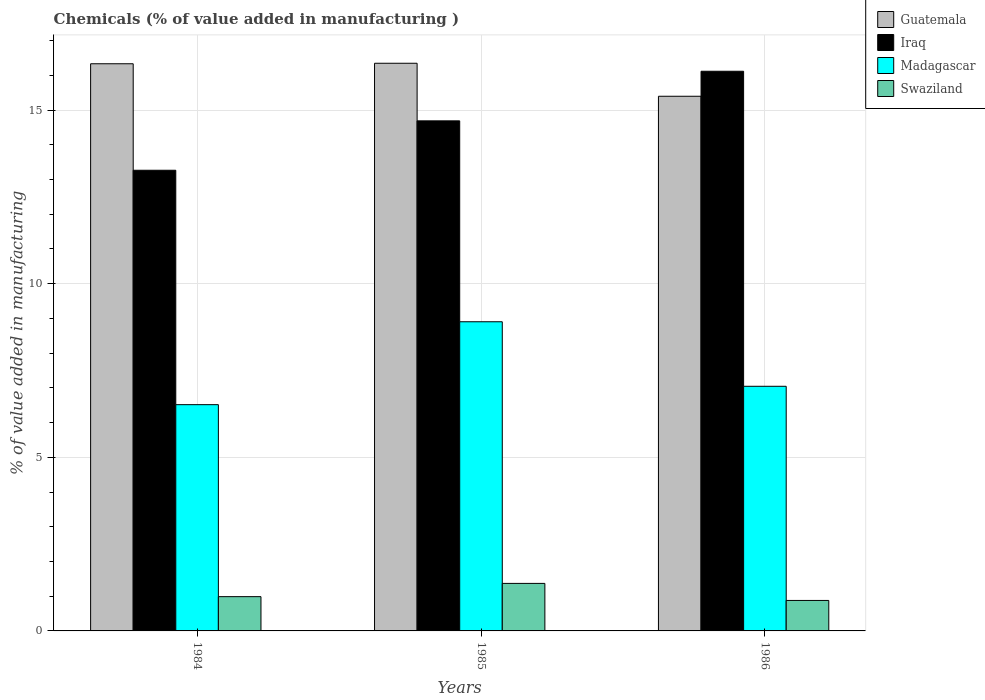Are the number of bars per tick equal to the number of legend labels?
Keep it short and to the point. Yes. How many bars are there on the 1st tick from the right?
Your answer should be compact. 4. What is the value added in manufacturing chemicals in Madagascar in 1985?
Keep it short and to the point. 8.9. Across all years, what is the maximum value added in manufacturing chemicals in Iraq?
Your answer should be compact. 16.12. Across all years, what is the minimum value added in manufacturing chemicals in Iraq?
Offer a terse response. 13.27. What is the total value added in manufacturing chemicals in Madagascar in the graph?
Offer a very short reply. 22.46. What is the difference between the value added in manufacturing chemicals in Iraq in 1985 and that in 1986?
Ensure brevity in your answer.  -1.43. What is the difference between the value added in manufacturing chemicals in Guatemala in 1986 and the value added in manufacturing chemicals in Swaziland in 1984?
Ensure brevity in your answer.  14.41. What is the average value added in manufacturing chemicals in Iraq per year?
Your response must be concise. 14.69. In the year 1986, what is the difference between the value added in manufacturing chemicals in Iraq and value added in manufacturing chemicals in Madagascar?
Make the answer very short. 9.07. What is the ratio of the value added in manufacturing chemicals in Madagascar in 1984 to that in 1985?
Keep it short and to the point. 0.73. What is the difference between the highest and the second highest value added in manufacturing chemicals in Madagascar?
Provide a short and direct response. 1.86. What is the difference between the highest and the lowest value added in manufacturing chemicals in Swaziland?
Offer a very short reply. 0.49. In how many years, is the value added in manufacturing chemicals in Iraq greater than the average value added in manufacturing chemicals in Iraq taken over all years?
Provide a succinct answer. 1. What does the 1st bar from the left in 1986 represents?
Ensure brevity in your answer.  Guatemala. What does the 2nd bar from the right in 1984 represents?
Your answer should be very brief. Madagascar. Is it the case that in every year, the sum of the value added in manufacturing chemicals in Iraq and value added in manufacturing chemicals in Madagascar is greater than the value added in manufacturing chemicals in Guatemala?
Ensure brevity in your answer.  Yes. Where does the legend appear in the graph?
Keep it short and to the point. Top right. What is the title of the graph?
Your response must be concise. Chemicals (% of value added in manufacturing ). What is the label or title of the Y-axis?
Offer a terse response. % of value added in manufacturing. What is the % of value added in manufacturing in Guatemala in 1984?
Your answer should be compact. 16.33. What is the % of value added in manufacturing in Iraq in 1984?
Provide a short and direct response. 13.27. What is the % of value added in manufacturing of Madagascar in 1984?
Keep it short and to the point. 6.52. What is the % of value added in manufacturing in Swaziland in 1984?
Keep it short and to the point. 0.99. What is the % of value added in manufacturing in Guatemala in 1985?
Keep it short and to the point. 16.35. What is the % of value added in manufacturing of Iraq in 1985?
Make the answer very short. 14.69. What is the % of value added in manufacturing of Madagascar in 1985?
Make the answer very short. 8.9. What is the % of value added in manufacturing of Swaziland in 1985?
Offer a terse response. 1.37. What is the % of value added in manufacturing of Guatemala in 1986?
Make the answer very short. 15.4. What is the % of value added in manufacturing of Iraq in 1986?
Give a very brief answer. 16.12. What is the % of value added in manufacturing in Madagascar in 1986?
Give a very brief answer. 7.04. What is the % of value added in manufacturing of Swaziland in 1986?
Make the answer very short. 0.88. Across all years, what is the maximum % of value added in manufacturing in Guatemala?
Make the answer very short. 16.35. Across all years, what is the maximum % of value added in manufacturing of Iraq?
Your answer should be very brief. 16.12. Across all years, what is the maximum % of value added in manufacturing in Madagascar?
Provide a short and direct response. 8.9. Across all years, what is the maximum % of value added in manufacturing of Swaziland?
Give a very brief answer. 1.37. Across all years, what is the minimum % of value added in manufacturing of Guatemala?
Your answer should be compact. 15.4. Across all years, what is the minimum % of value added in manufacturing of Iraq?
Offer a very short reply. 13.27. Across all years, what is the minimum % of value added in manufacturing of Madagascar?
Ensure brevity in your answer.  6.52. Across all years, what is the minimum % of value added in manufacturing of Swaziland?
Your answer should be compact. 0.88. What is the total % of value added in manufacturing in Guatemala in the graph?
Offer a terse response. 48.08. What is the total % of value added in manufacturing of Iraq in the graph?
Your answer should be compact. 44.07. What is the total % of value added in manufacturing of Madagascar in the graph?
Your answer should be very brief. 22.46. What is the total % of value added in manufacturing in Swaziland in the graph?
Ensure brevity in your answer.  3.23. What is the difference between the % of value added in manufacturing in Guatemala in 1984 and that in 1985?
Keep it short and to the point. -0.01. What is the difference between the % of value added in manufacturing in Iraq in 1984 and that in 1985?
Make the answer very short. -1.42. What is the difference between the % of value added in manufacturing of Madagascar in 1984 and that in 1985?
Offer a very short reply. -2.39. What is the difference between the % of value added in manufacturing of Swaziland in 1984 and that in 1985?
Ensure brevity in your answer.  -0.38. What is the difference between the % of value added in manufacturing of Guatemala in 1984 and that in 1986?
Keep it short and to the point. 0.94. What is the difference between the % of value added in manufacturing of Iraq in 1984 and that in 1986?
Make the answer very short. -2.85. What is the difference between the % of value added in manufacturing in Madagascar in 1984 and that in 1986?
Your answer should be compact. -0.53. What is the difference between the % of value added in manufacturing of Swaziland in 1984 and that in 1986?
Your response must be concise. 0.11. What is the difference between the % of value added in manufacturing in Guatemala in 1985 and that in 1986?
Give a very brief answer. 0.95. What is the difference between the % of value added in manufacturing of Iraq in 1985 and that in 1986?
Provide a short and direct response. -1.43. What is the difference between the % of value added in manufacturing in Madagascar in 1985 and that in 1986?
Your response must be concise. 1.86. What is the difference between the % of value added in manufacturing of Swaziland in 1985 and that in 1986?
Provide a succinct answer. 0.49. What is the difference between the % of value added in manufacturing in Guatemala in 1984 and the % of value added in manufacturing in Iraq in 1985?
Give a very brief answer. 1.64. What is the difference between the % of value added in manufacturing in Guatemala in 1984 and the % of value added in manufacturing in Madagascar in 1985?
Offer a terse response. 7.43. What is the difference between the % of value added in manufacturing of Guatemala in 1984 and the % of value added in manufacturing of Swaziland in 1985?
Your answer should be very brief. 14.96. What is the difference between the % of value added in manufacturing of Iraq in 1984 and the % of value added in manufacturing of Madagascar in 1985?
Provide a succinct answer. 4.36. What is the difference between the % of value added in manufacturing in Iraq in 1984 and the % of value added in manufacturing in Swaziland in 1985?
Your answer should be very brief. 11.9. What is the difference between the % of value added in manufacturing in Madagascar in 1984 and the % of value added in manufacturing in Swaziland in 1985?
Provide a short and direct response. 5.15. What is the difference between the % of value added in manufacturing in Guatemala in 1984 and the % of value added in manufacturing in Iraq in 1986?
Your answer should be very brief. 0.22. What is the difference between the % of value added in manufacturing of Guatemala in 1984 and the % of value added in manufacturing of Madagascar in 1986?
Your answer should be very brief. 9.29. What is the difference between the % of value added in manufacturing in Guatemala in 1984 and the % of value added in manufacturing in Swaziland in 1986?
Make the answer very short. 15.46. What is the difference between the % of value added in manufacturing in Iraq in 1984 and the % of value added in manufacturing in Madagascar in 1986?
Ensure brevity in your answer.  6.22. What is the difference between the % of value added in manufacturing in Iraq in 1984 and the % of value added in manufacturing in Swaziland in 1986?
Your answer should be compact. 12.39. What is the difference between the % of value added in manufacturing in Madagascar in 1984 and the % of value added in manufacturing in Swaziland in 1986?
Offer a very short reply. 5.64. What is the difference between the % of value added in manufacturing in Guatemala in 1985 and the % of value added in manufacturing in Iraq in 1986?
Your answer should be compact. 0.23. What is the difference between the % of value added in manufacturing in Guatemala in 1985 and the % of value added in manufacturing in Madagascar in 1986?
Your answer should be compact. 9.3. What is the difference between the % of value added in manufacturing of Guatemala in 1985 and the % of value added in manufacturing of Swaziland in 1986?
Give a very brief answer. 15.47. What is the difference between the % of value added in manufacturing of Iraq in 1985 and the % of value added in manufacturing of Madagascar in 1986?
Offer a terse response. 7.64. What is the difference between the % of value added in manufacturing of Iraq in 1985 and the % of value added in manufacturing of Swaziland in 1986?
Your answer should be compact. 13.81. What is the difference between the % of value added in manufacturing in Madagascar in 1985 and the % of value added in manufacturing in Swaziland in 1986?
Give a very brief answer. 8.03. What is the average % of value added in manufacturing in Guatemala per year?
Provide a succinct answer. 16.03. What is the average % of value added in manufacturing in Iraq per year?
Give a very brief answer. 14.69. What is the average % of value added in manufacturing in Madagascar per year?
Your answer should be compact. 7.49. What is the average % of value added in manufacturing in Swaziland per year?
Offer a terse response. 1.08. In the year 1984, what is the difference between the % of value added in manufacturing of Guatemala and % of value added in manufacturing of Iraq?
Keep it short and to the point. 3.07. In the year 1984, what is the difference between the % of value added in manufacturing in Guatemala and % of value added in manufacturing in Madagascar?
Make the answer very short. 9.82. In the year 1984, what is the difference between the % of value added in manufacturing of Guatemala and % of value added in manufacturing of Swaziland?
Offer a very short reply. 15.35. In the year 1984, what is the difference between the % of value added in manufacturing of Iraq and % of value added in manufacturing of Madagascar?
Make the answer very short. 6.75. In the year 1984, what is the difference between the % of value added in manufacturing in Iraq and % of value added in manufacturing in Swaziland?
Ensure brevity in your answer.  12.28. In the year 1984, what is the difference between the % of value added in manufacturing of Madagascar and % of value added in manufacturing of Swaziland?
Ensure brevity in your answer.  5.53. In the year 1985, what is the difference between the % of value added in manufacturing of Guatemala and % of value added in manufacturing of Iraq?
Provide a short and direct response. 1.66. In the year 1985, what is the difference between the % of value added in manufacturing of Guatemala and % of value added in manufacturing of Madagascar?
Make the answer very short. 7.44. In the year 1985, what is the difference between the % of value added in manufacturing of Guatemala and % of value added in manufacturing of Swaziland?
Your response must be concise. 14.98. In the year 1985, what is the difference between the % of value added in manufacturing in Iraq and % of value added in manufacturing in Madagascar?
Provide a succinct answer. 5.79. In the year 1985, what is the difference between the % of value added in manufacturing in Iraq and % of value added in manufacturing in Swaziland?
Keep it short and to the point. 13.32. In the year 1985, what is the difference between the % of value added in manufacturing of Madagascar and % of value added in manufacturing of Swaziland?
Offer a very short reply. 7.53. In the year 1986, what is the difference between the % of value added in manufacturing in Guatemala and % of value added in manufacturing in Iraq?
Offer a terse response. -0.72. In the year 1986, what is the difference between the % of value added in manufacturing in Guatemala and % of value added in manufacturing in Madagascar?
Provide a short and direct response. 8.35. In the year 1986, what is the difference between the % of value added in manufacturing in Guatemala and % of value added in manufacturing in Swaziland?
Ensure brevity in your answer.  14.52. In the year 1986, what is the difference between the % of value added in manufacturing in Iraq and % of value added in manufacturing in Madagascar?
Offer a very short reply. 9.07. In the year 1986, what is the difference between the % of value added in manufacturing of Iraq and % of value added in manufacturing of Swaziland?
Offer a very short reply. 15.24. In the year 1986, what is the difference between the % of value added in manufacturing of Madagascar and % of value added in manufacturing of Swaziland?
Ensure brevity in your answer.  6.17. What is the ratio of the % of value added in manufacturing in Iraq in 1984 to that in 1985?
Give a very brief answer. 0.9. What is the ratio of the % of value added in manufacturing in Madagascar in 1984 to that in 1985?
Offer a very short reply. 0.73. What is the ratio of the % of value added in manufacturing in Swaziland in 1984 to that in 1985?
Your answer should be compact. 0.72. What is the ratio of the % of value added in manufacturing in Guatemala in 1984 to that in 1986?
Provide a succinct answer. 1.06. What is the ratio of the % of value added in manufacturing of Iraq in 1984 to that in 1986?
Give a very brief answer. 0.82. What is the ratio of the % of value added in manufacturing in Madagascar in 1984 to that in 1986?
Your answer should be very brief. 0.92. What is the ratio of the % of value added in manufacturing in Swaziland in 1984 to that in 1986?
Your response must be concise. 1.12. What is the ratio of the % of value added in manufacturing of Guatemala in 1985 to that in 1986?
Your answer should be compact. 1.06. What is the ratio of the % of value added in manufacturing of Iraq in 1985 to that in 1986?
Your response must be concise. 0.91. What is the ratio of the % of value added in manufacturing of Madagascar in 1985 to that in 1986?
Your response must be concise. 1.26. What is the ratio of the % of value added in manufacturing in Swaziland in 1985 to that in 1986?
Provide a short and direct response. 1.56. What is the difference between the highest and the second highest % of value added in manufacturing of Guatemala?
Make the answer very short. 0.01. What is the difference between the highest and the second highest % of value added in manufacturing in Iraq?
Keep it short and to the point. 1.43. What is the difference between the highest and the second highest % of value added in manufacturing of Madagascar?
Ensure brevity in your answer.  1.86. What is the difference between the highest and the second highest % of value added in manufacturing of Swaziland?
Your response must be concise. 0.38. What is the difference between the highest and the lowest % of value added in manufacturing in Guatemala?
Make the answer very short. 0.95. What is the difference between the highest and the lowest % of value added in manufacturing of Iraq?
Make the answer very short. 2.85. What is the difference between the highest and the lowest % of value added in manufacturing of Madagascar?
Your answer should be very brief. 2.39. What is the difference between the highest and the lowest % of value added in manufacturing of Swaziland?
Provide a short and direct response. 0.49. 